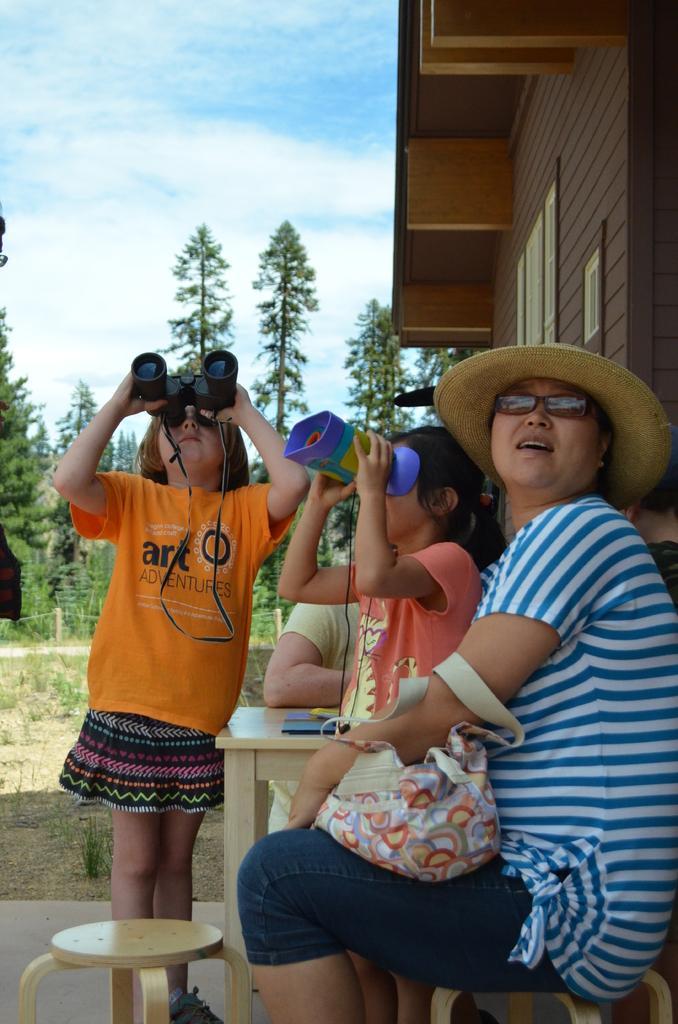Can you describe this image briefly? In this image i can see group of people and a house. I can also see a sky and few trees. 